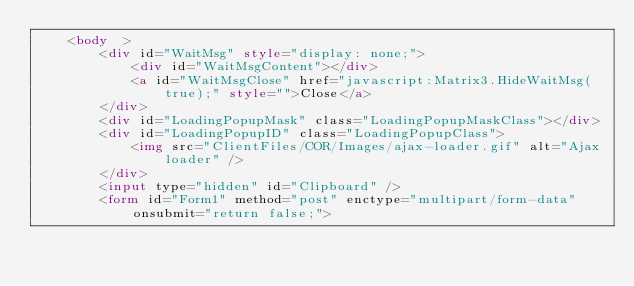<code> <loc_0><loc_0><loc_500><loc_500><_HTML_>    <body  >
        <div id="WaitMsg" style="display: none;">
            <div id="WaitMsgContent"></div>
            <a id="WaitMsgClose" href="javascript:Matrix3.HideWaitMsg(true);" style="">Close</a>
        </div>
        <div id="LoadingPopupMask" class="LoadingPopupMaskClass"></div>
        <div id="LoadingPopupID" class="LoadingPopupClass">
            <img src="ClientFiles/COR/Images/ajax-loader.gif" alt="Ajax loader" />
        </div>
		<input type="hidden" id="Clipboard" />
		<form id="Form1" method="post" enctype="multipart/form-data" onsubmit="return false;"></code> 